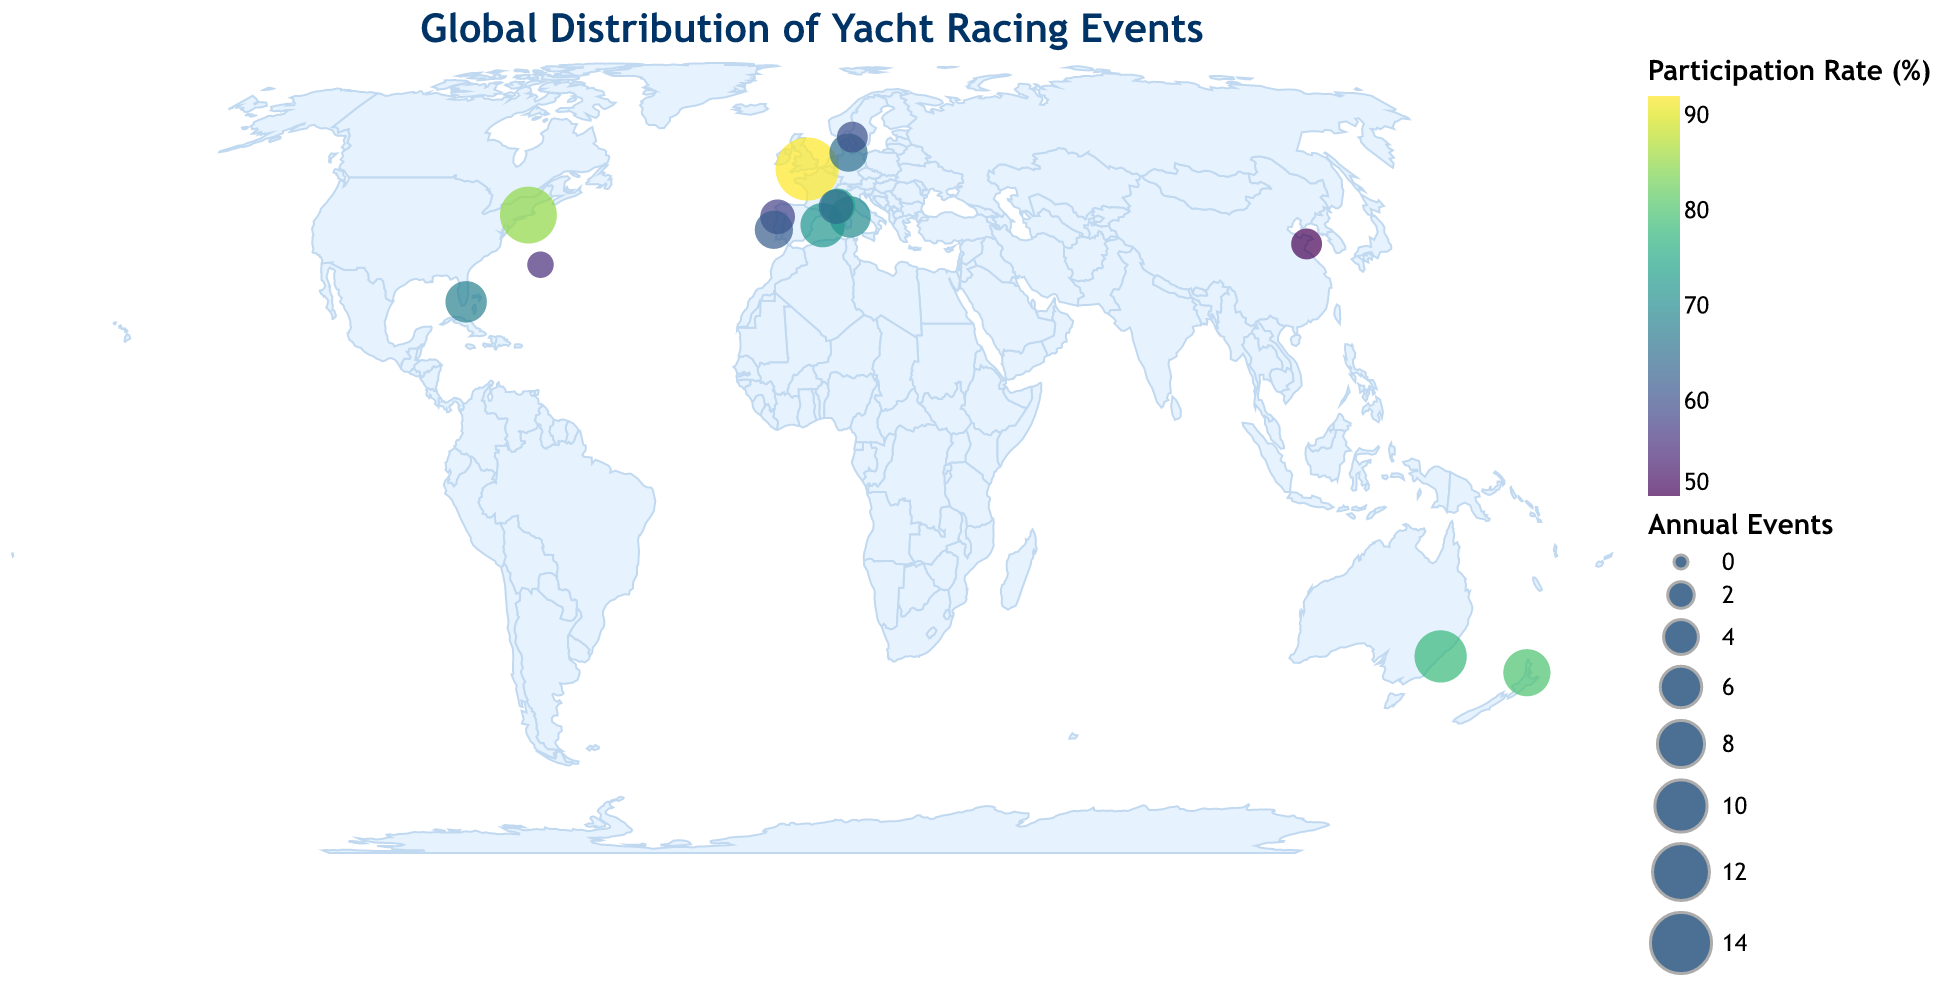What's the title of the plot? The title is usually found at the top of the plot and provides a brief description of what the plot represents.
Answer: Global Distribution of Yacht Racing Events Which location has the highest annual number of yacht racing events? By looking at the size of the circles on the plot, the largest circle indicates the highest number of annual events.
Answer: Cowes (UK) Which location has the lowest participation rate in yacht racing events? The color gradient indicates participation rate, with the lightest color representing the lowest rate.
Answer: Qingdao (China) How many locations are there with participation rates above 75%? Identify the circles colored with shades representing participation rates above 75% on the plot. Locations with participation rates above 75% are Newport (USA), Cowes (UK), Saint-Tropez (France).
Answer: 3 What is the combined annual number of events for the locations in Portugal? The locations in Portugal are Cascais and Porto. Add their annual events: 5 (Cascais) + 4 (Porto).
Answer: 9 Which area, Australia or New Zealand, has a higher participation rate? Compare the colors of the circles for Sydney (Australia) and Auckland (New Zealand). Auckland has a darker color, indicating a higher rate.
Answer: New Zealand Is there any location in South America listed on the plot? By examining the plot, check for any circles over the South American continent.
Answer: No Which location has more annual events, Miami or Palma de Mallorca? Compare the sizes of the circles representing Miami and Palma de Mallorca. Palma de Mallorca has more annual events (7) than Miami (6).
Answer: Palma de Mallorca Which locations in the northern hemisphere have an annual event count greater than 5? Identify the locations in the northern hemisphere (positive latitudes) and then check their annual event counts: Newport (USA), Cowes (UK).
Answer: 2 locations (Newport, Cowes) Comparing Hamilton (Bermuda) and Porto Cervo (Italy), which has a higher participation rate? Compare the colors of the circles representing Hamilton and Porto Cervo. Porto Cervo has a darker shade compared to Hamilton.
Answer: Porto Cervo (Italy) 